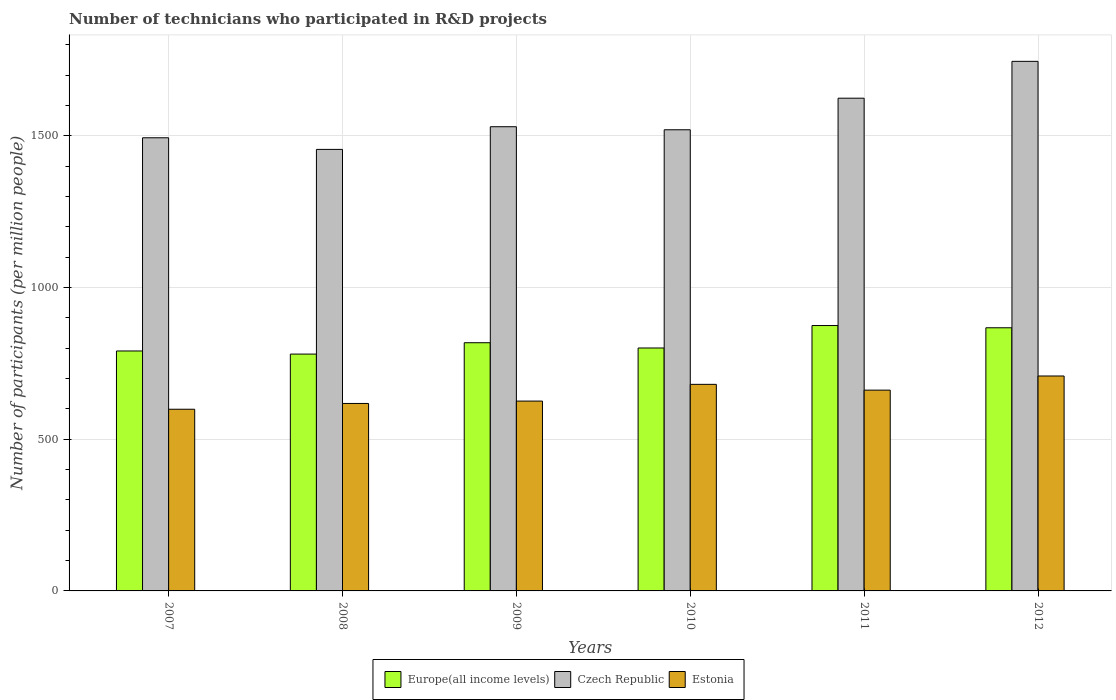How many different coloured bars are there?
Make the answer very short. 3. How many groups of bars are there?
Keep it short and to the point. 6. Are the number of bars per tick equal to the number of legend labels?
Your answer should be very brief. Yes. Are the number of bars on each tick of the X-axis equal?
Offer a terse response. Yes. How many bars are there on the 6th tick from the left?
Make the answer very short. 3. What is the label of the 6th group of bars from the left?
Ensure brevity in your answer.  2012. What is the number of technicians who participated in R&D projects in Czech Republic in 2009?
Keep it short and to the point. 1530.09. Across all years, what is the maximum number of technicians who participated in R&D projects in Czech Republic?
Your answer should be very brief. 1745.59. Across all years, what is the minimum number of technicians who participated in R&D projects in Estonia?
Your answer should be compact. 598.85. In which year was the number of technicians who participated in R&D projects in Estonia maximum?
Keep it short and to the point. 2012. What is the total number of technicians who participated in R&D projects in Estonia in the graph?
Ensure brevity in your answer.  3893.72. What is the difference between the number of technicians who participated in R&D projects in Estonia in 2008 and that in 2009?
Give a very brief answer. -7.8. What is the difference between the number of technicians who participated in R&D projects in Estonia in 2008 and the number of technicians who participated in R&D projects in Czech Republic in 2012?
Your answer should be very brief. -1127.65. What is the average number of technicians who participated in R&D projects in Europe(all income levels) per year?
Your response must be concise. 822.1. In the year 2009, what is the difference between the number of technicians who participated in R&D projects in Europe(all income levels) and number of technicians who participated in R&D projects in Czech Republic?
Provide a short and direct response. -712. What is the ratio of the number of technicians who participated in R&D projects in Estonia in 2007 to that in 2011?
Make the answer very short. 0.9. What is the difference between the highest and the second highest number of technicians who participated in R&D projects in Europe(all income levels)?
Your answer should be compact. 7.39. What is the difference between the highest and the lowest number of technicians who participated in R&D projects in Estonia?
Offer a terse response. 109.58. What does the 3rd bar from the left in 2008 represents?
Keep it short and to the point. Estonia. What does the 1st bar from the right in 2012 represents?
Make the answer very short. Estonia. Is it the case that in every year, the sum of the number of technicians who participated in R&D projects in Europe(all income levels) and number of technicians who participated in R&D projects in Estonia is greater than the number of technicians who participated in R&D projects in Czech Republic?
Your response must be concise. No. What is the difference between two consecutive major ticks on the Y-axis?
Provide a succinct answer. 500. Are the values on the major ticks of Y-axis written in scientific E-notation?
Your answer should be compact. No. Does the graph contain grids?
Provide a succinct answer. Yes. How many legend labels are there?
Keep it short and to the point. 3. How are the legend labels stacked?
Offer a terse response. Horizontal. What is the title of the graph?
Give a very brief answer. Number of technicians who participated in R&D projects. Does "East Asia (all income levels)" appear as one of the legend labels in the graph?
Offer a terse response. No. What is the label or title of the Y-axis?
Your answer should be very brief. Number of participants (per million people). What is the Number of participants (per million people) in Europe(all income levels) in 2007?
Offer a terse response. 790.9. What is the Number of participants (per million people) in Czech Republic in 2007?
Offer a terse response. 1493.68. What is the Number of participants (per million people) in Estonia in 2007?
Provide a short and direct response. 598.85. What is the Number of participants (per million people) of Europe(all income levels) in 2008?
Offer a terse response. 780.67. What is the Number of participants (per million people) of Czech Republic in 2008?
Ensure brevity in your answer.  1455.38. What is the Number of participants (per million people) in Estonia in 2008?
Your answer should be compact. 617.94. What is the Number of participants (per million people) of Europe(all income levels) in 2009?
Provide a short and direct response. 818.09. What is the Number of participants (per million people) in Czech Republic in 2009?
Your response must be concise. 1530.09. What is the Number of participants (per million people) of Estonia in 2009?
Your response must be concise. 625.74. What is the Number of participants (per million people) in Europe(all income levels) in 2010?
Your answer should be compact. 800.78. What is the Number of participants (per million people) in Czech Republic in 2010?
Offer a very short reply. 1520.06. What is the Number of participants (per million people) of Estonia in 2010?
Offer a very short reply. 680.89. What is the Number of participants (per million people) of Europe(all income levels) in 2011?
Offer a terse response. 874.77. What is the Number of participants (per million people) in Czech Republic in 2011?
Provide a succinct answer. 1624.14. What is the Number of participants (per million people) of Estonia in 2011?
Ensure brevity in your answer.  661.86. What is the Number of participants (per million people) of Europe(all income levels) in 2012?
Provide a succinct answer. 867.37. What is the Number of participants (per million people) of Czech Republic in 2012?
Offer a very short reply. 1745.59. What is the Number of participants (per million people) in Estonia in 2012?
Offer a terse response. 708.44. Across all years, what is the maximum Number of participants (per million people) of Europe(all income levels)?
Give a very brief answer. 874.77. Across all years, what is the maximum Number of participants (per million people) in Czech Republic?
Provide a succinct answer. 1745.59. Across all years, what is the maximum Number of participants (per million people) in Estonia?
Offer a very short reply. 708.44. Across all years, what is the minimum Number of participants (per million people) of Europe(all income levels)?
Your response must be concise. 780.67. Across all years, what is the minimum Number of participants (per million people) of Czech Republic?
Offer a very short reply. 1455.38. Across all years, what is the minimum Number of participants (per million people) in Estonia?
Provide a short and direct response. 598.85. What is the total Number of participants (per million people) in Europe(all income levels) in the graph?
Your response must be concise. 4932.59. What is the total Number of participants (per million people) of Czech Republic in the graph?
Keep it short and to the point. 9368.93. What is the total Number of participants (per million people) in Estonia in the graph?
Make the answer very short. 3893.72. What is the difference between the Number of participants (per million people) of Europe(all income levels) in 2007 and that in 2008?
Ensure brevity in your answer.  10.23. What is the difference between the Number of participants (per million people) of Czech Republic in 2007 and that in 2008?
Your answer should be very brief. 38.3. What is the difference between the Number of participants (per million people) of Estonia in 2007 and that in 2008?
Your answer should be compact. -19.08. What is the difference between the Number of participants (per million people) of Europe(all income levels) in 2007 and that in 2009?
Offer a very short reply. -27.19. What is the difference between the Number of participants (per million people) of Czech Republic in 2007 and that in 2009?
Provide a succinct answer. -36.41. What is the difference between the Number of participants (per million people) in Estonia in 2007 and that in 2009?
Your response must be concise. -26.89. What is the difference between the Number of participants (per million people) in Europe(all income levels) in 2007 and that in 2010?
Your response must be concise. -9.87. What is the difference between the Number of participants (per million people) in Czech Republic in 2007 and that in 2010?
Ensure brevity in your answer.  -26.38. What is the difference between the Number of participants (per million people) of Estonia in 2007 and that in 2010?
Give a very brief answer. -82.03. What is the difference between the Number of participants (per million people) of Europe(all income levels) in 2007 and that in 2011?
Your answer should be compact. -83.87. What is the difference between the Number of participants (per million people) in Czech Republic in 2007 and that in 2011?
Offer a very short reply. -130.45. What is the difference between the Number of participants (per million people) of Estonia in 2007 and that in 2011?
Keep it short and to the point. -63.01. What is the difference between the Number of participants (per million people) of Europe(all income levels) in 2007 and that in 2012?
Provide a short and direct response. -76.47. What is the difference between the Number of participants (per million people) of Czech Republic in 2007 and that in 2012?
Your answer should be very brief. -251.9. What is the difference between the Number of participants (per million people) in Estonia in 2007 and that in 2012?
Provide a short and direct response. -109.58. What is the difference between the Number of participants (per million people) of Europe(all income levels) in 2008 and that in 2009?
Your response must be concise. -37.42. What is the difference between the Number of participants (per million people) of Czech Republic in 2008 and that in 2009?
Offer a terse response. -74.72. What is the difference between the Number of participants (per million people) in Estonia in 2008 and that in 2009?
Keep it short and to the point. -7.8. What is the difference between the Number of participants (per million people) in Europe(all income levels) in 2008 and that in 2010?
Provide a succinct answer. -20.1. What is the difference between the Number of participants (per million people) of Czech Republic in 2008 and that in 2010?
Offer a very short reply. -64.68. What is the difference between the Number of participants (per million people) of Estonia in 2008 and that in 2010?
Your answer should be very brief. -62.95. What is the difference between the Number of participants (per million people) of Europe(all income levels) in 2008 and that in 2011?
Your answer should be very brief. -94.09. What is the difference between the Number of participants (per million people) in Czech Republic in 2008 and that in 2011?
Make the answer very short. -168.76. What is the difference between the Number of participants (per million people) of Estonia in 2008 and that in 2011?
Your answer should be compact. -43.93. What is the difference between the Number of participants (per million people) in Europe(all income levels) in 2008 and that in 2012?
Ensure brevity in your answer.  -86.7. What is the difference between the Number of participants (per million people) in Czech Republic in 2008 and that in 2012?
Ensure brevity in your answer.  -290.21. What is the difference between the Number of participants (per million people) of Estonia in 2008 and that in 2012?
Offer a terse response. -90.5. What is the difference between the Number of participants (per million people) in Europe(all income levels) in 2009 and that in 2010?
Your response must be concise. 17.32. What is the difference between the Number of participants (per million people) in Czech Republic in 2009 and that in 2010?
Provide a short and direct response. 10.04. What is the difference between the Number of participants (per million people) of Estonia in 2009 and that in 2010?
Provide a short and direct response. -55.14. What is the difference between the Number of participants (per million people) in Europe(all income levels) in 2009 and that in 2011?
Give a very brief answer. -56.67. What is the difference between the Number of participants (per million people) in Czech Republic in 2009 and that in 2011?
Give a very brief answer. -94.04. What is the difference between the Number of participants (per million people) in Estonia in 2009 and that in 2011?
Provide a succinct answer. -36.12. What is the difference between the Number of participants (per million people) in Europe(all income levels) in 2009 and that in 2012?
Make the answer very short. -49.28. What is the difference between the Number of participants (per million people) in Czech Republic in 2009 and that in 2012?
Ensure brevity in your answer.  -215.49. What is the difference between the Number of participants (per million people) in Estonia in 2009 and that in 2012?
Ensure brevity in your answer.  -82.7. What is the difference between the Number of participants (per million people) of Europe(all income levels) in 2010 and that in 2011?
Offer a terse response. -73.99. What is the difference between the Number of participants (per million people) of Czech Republic in 2010 and that in 2011?
Your response must be concise. -104.08. What is the difference between the Number of participants (per million people) of Estonia in 2010 and that in 2011?
Provide a succinct answer. 19.02. What is the difference between the Number of participants (per million people) in Europe(all income levels) in 2010 and that in 2012?
Offer a very short reply. -66.6. What is the difference between the Number of participants (per million people) in Czech Republic in 2010 and that in 2012?
Ensure brevity in your answer.  -225.53. What is the difference between the Number of participants (per million people) in Estonia in 2010 and that in 2012?
Ensure brevity in your answer.  -27.55. What is the difference between the Number of participants (per million people) in Europe(all income levels) in 2011 and that in 2012?
Your response must be concise. 7.39. What is the difference between the Number of participants (per million people) of Czech Republic in 2011 and that in 2012?
Your answer should be very brief. -121.45. What is the difference between the Number of participants (per million people) in Estonia in 2011 and that in 2012?
Your answer should be very brief. -46.57. What is the difference between the Number of participants (per million people) in Europe(all income levels) in 2007 and the Number of participants (per million people) in Czech Republic in 2008?
Provide a short and direct response. -664.47. What is the difference between the Number of participants (per million people) in Europe(all income levels) in 2007 and the Number of participants (per million people) in Estonia in 2008?
Offer a terse response. 172.97. What is the difference between the Number of participants (per million people) in Czech Republic in 2007 and the Number of participants (per million people) in Estonia in 2008?
Offer a terse response. 875.74. What is the difference between the Number of participants (per million people) in Europe(all income levels) in 2007 and the Number of participants (per million people) in Czech Republic in 2009?
Your answer should be very brief. -739.19. What is the difference between the Number of participants (per million people) in Europe(all income levels) in 2007 and the Number of participants (per million people) in Estonia in 2009?
Give a very brief answer. 165.16. What is the difference between the Number of participants (per million people) in Czech Republic in 2007 and the Number of participants (per million people) in Estonia in 2009?
Make the answer very short. 867.94. What is the difference between the Number of participants (per million people) in Europe(all income levels) in 2007 and the Number of participants (per million people) in Czech Republic in 2010?
Offer a terse response. -729.15. What is the difference between the Number of participants (per million people) of Europe(all income levels) in 2007 and the Number of participants (per million people) of Estonia in 2010?
Keep it short and to the point. 110.02. What is the difference between the Number of participants (per million people) in Czech Republic in 2007 and the Number of participants (per million people) in Estonia in 2010?
Your answer should be very brief. 812.8. What is the difference between the Number of participants (per million people) in Europe(all income levels) in 2007 and the Number of participants (per million people) in Czech Republic in 2011?
Offer a terse response. -833.23. What is the difference between the Number of participants (per million people) in Europe(all income levels) in 2007 and the Number of participants (per million people) in Estonia in 2011?
Provide a short and direct response. 129.04. What is the difference between the Number of participants (per million people) of Czech Republic in 2007 and the Number of participants (per million people) of Estonia in 2011?
Provide a short and direct response. 831.82. What is the difference between the Number of participants (per million people) of Europe(all income levels) in 2007 and the Number of participants (per million people) of Czech Republic in 2012?
Provide a short and direct response. -954.68. What is the difference between the Number of participants (per million people) in Europe(all income levels) in 2007 and the Number of participants (per million people) in Estonia in 2012?
Your answer should be compact. 82.46. What is the difference between the Number of participants (per million people) in Czech Republic in 2007 and the Number of participants (per million people) in Estonia in 2012?
Your response must be concise. 785.24. What is the difference between the Number of participants (per million people) in Europe(all income levels) in 2008 and the Number of participants (per million people) in Czech Republic in 2009?
Your answer should be very brief. -749.42. What is the difference between the Number of participants (per million people) in Europe(all income levels) in 2008 and the Number of participants (per million people) in Estonia in 2009?
Offer a terse response. 154.93. What is the difference between the Number of participants (per million people) in Czech Republic in 2008 and the Number of participants (per million people) in Estonia in 2009?
Provide a short and direct response. 829.63. What is the difference between the Number of participants (per million people) in Europe(all income levels) in 2008 and the Number of participants (per million people) in Czech Republic in 2010?
Make the answer very short. -739.38. What is the difference between the Number of participants (per million people) of Europe(all income levels) in 2008 and the Number of participants (per million people) of Estonia in 2010?
Offer a terse response. 99.79. What is the difference between the Number of participants (per million people) in Czech Republic in 2008 and the Number of participants (per million people) in Estonia in 2010?
Make the answer very short. 774.49. What is the difference between the Number of participants (per million people) of Europe(all income levels) in 2008 and the Number of participants (per million people) of Czech Republic in 2011?
Provide a short and direct response. -843.46. What is the difference between the Number of participants (per million people) of Europe(all income levels) in 2008 and the Number of participants (per million people) of Estonia in 2011?
Your answer should be very brief. 118.81. What is the difference between the Number of participants (per million people) of Czech Republic in 2008 and the Number of participants (per million people) of Estonia in 2011?
Offer a terse response. 793.51. What is the difference between the Number of participants (per million people) in Europe(all income levels) in 2008 and the Number of participants (per million people) in Czech Republic in 2012?
Your response must be concise. -964.91. What is the difference between the Number of participants (per million people) in Europe(all income levels) in 2008 and the Number of participants (per million people) in Estonia in 2012?
Keep it short and to the point. 72.24. What is the difference between the Number of participants (per million people) of Czech Republic in 2008 and the Number of participants (per million people) of Estonia in 2012?
Your answer should be very brief. 746.94. What is the difference between the Number of participants (per million people) of Europe(all income levels) in 2009 and the Number of participants (per million people) of Czech Republic in 2010?
Give a very brief answer. -701.96. What is the difference between the Number of participants (per million people) of Europe(all income levels) in 2009 and the Number of participants (per million people) of Estonia in 2010?
Your answer should be compact. 137.21. What is the difference between the Number of participants (per million people) of Czech Republic in 2009 and the Number of participants (per million people) of Estonia in 2010?
Give a very brief answer. 849.21. What is the difference between the Number of participants (per million people) in Europe(all income levels) in 2009 and the Number of participants (per million people) in Czech Republic in 2011?
Ensure brevity in your answer.  -806.04. What is the difference between the Number of participants (per million people) in Europe(all income levels) in 2009 and the Number of participants (per million people) in Estonia in 2011?
Provide a succinct answer. 156.23. What is the difference between the Number of participants (per million people) of Czech Republic in 2009 and the Number of participants (per million people) of Estonia in 2011?
Offer a terse response. 868.23. What is the difference between the Number of participants (per million people) of Europe(all income levels) in 2009 and the Number of participants (per million people) of Czech Republic in 2012?
Give a very brief answer. -927.49. What is the difference between the Number of participants (per million people) of Europe(all income levels) in 2009 and the Number of participants (per million people) of Estonia in 2012?
Provide a short and direct response. 109.66. What is the difference between the Number of participants (per million people) in Czech Republic in 2009 and the Number of participants (per million people) in Estonia in 2012?
Give a very brief answer. 821.66. What is the difference between the Number of participants (per million people) of Europe(all income levels) in 2010 and the Number of participants (per million people) of Czech Republic in 2011?
Ensure brevity in your answer.  -823.36. What is the difference between the Number of participants (per million people) in Europe(all income levels) in 2010 and the Number of participants (per million people) in Estonia in 2011?
Ensure brevity in your answer.  138.91. What is the difference between the Number of participants (per million people) in Czech Republic in 2010 and the Number of participants (per million people) in Estonia in 2011?
Ensure brevity in your answer.  858.19. What is the difference between the Number of participants (per million people) in Europe(all income levels) in 2010 and the Number of participants (per million people) in Czech Republic in 2012?
Offer a terse response. -944.81. What is the difference between the Number of participants (per million people) in Europe(all income levels) in 2010 and the Number of participants (per million people) in Estonia in 2012?
Give a very brief answer. 92.34. What is the difference between the Number of participants (per million people) of Czech Republic in 2010 and the Number of participants (per million people) of Estonia in 2012?
Make the answer very short. 811.62. What is the difference between the Number of participants (per million people) in Europe(all income levels) in 2011 and the Number of participants (per million people) in Czech Republic in 2012?
Offer a terse response. -870.82. What is the difference between the Number of participants (per million people) of Europe(all income levels) in 2011 and the Number of participants (per million people) of Estonia in 2012?
Give a very brief answer. 166.33. What is the difference between the Number of participants (per million people) of Czech Republic in 2011 and the Number of participants (per million people) of Estonia in 2012?
Keep it short and to the point. 915.7. What is the average Number of participants (per million people) in Europe(all income levels) per year?
Keep it short and to the point. 822.1. What is the average Number of participants (per million people) in Czech Republic per year?
Provide a succinct answer. 1561.49. What is the average Number of participants (per million people) of Estonia per year?
Provide a succinct answer. 648.95. In the year 2007, what is the difference between the Number of participants (per million people) of Europe(all income levels) and Number of participants (per million people) of Czech Republic?
Your answer should be very brief. -702.78. In the year 2007, what is the difference between the Number of participants (per million people) of Europe(all income levels) and Number of participants (per million people) of Estonia?
Make the answer very short. 192.05. In the year 2007, what is the difference between the Number of participants (per million people) in Czech Republic and Number of participants (per million people) in Estonia?
Your answer should be compact. 894.83. In the year 2008, what is the difference between the Number of participants (per million people) of Europe(all income levels) and Number of participants (per million people) of Czech Republic?
Give a very brief answer. -674.7. In the year 2008, what is the difference between the Number of participants (per million people) in Europe(all income levels) and Number of participants (per million people) in Estonia?
Your answer should be compact. 162.74. In the year 2008, what is the difference between the Number of participants (per million people) in Czech Republic and Number of participants (per million people) in Estonia?
Make the answer very short. 837.44. In the year 2009, what is the difference between the Number of participants (per million people) in Europe(all income levels) and Number of participants (per million people) in Czech Republic?
Your response must be concise. -712. In the year 2009, what is the difference between the Number of participants (per million people) of Europe(all income levels) and Number of participants (per million people) of Estonia?
Keep it short and to the point. 192.35. In the year 2009, what is the difference between the Number of participants (per million people) in Czech Republic and Number of participants (per million people) in Estonia?
Provide a succinct answer. 904.35. In the year 2010, what is the difference between the Number of participants (per million people) of Europe(all income levels) and Number of participants (per million people) of Czech Republic?
Your answer should be compact. -719.28. In the year 2010, what is the difference between the Number of participants (per million people) in Europe(all income levels) and Number of participants (per million people) in Estonia?
Ensure brevity in your answer.  119.89. In the year 2010, what is the difference between the Number of participants (per million people) of Czech Republic and Number of participants (per million people) of Estonia?
Provide a succinct answer. 839.17. In the year 2011, what is the difference between the Number of participants (per million people) of Europe(all income levels) and Number of participants (per million people) of Czech Republic?
Make the answer very short. -749.37. In the year 2011, what is the difference between the Number of participants (per million people) in Europe(all income levels) and Number of participants (per million people) in Estonia?
Provide a succinct answer. 212.9. In the year 2011, what is the difference between the Number of participants (per million people) of Czech Republic and Number of participants (per million people) of Estonia?
Provide a succinct answer. 962.27. In the year 2012, what is the difference between the Number of participants (per million people) of Europe(all income levels) and Number of participants (per million people) of Czech Republic?
Your answer should be very brief. -878.21. In the year 2012, what is the difference between the Number of participants (per million people) in Europe(all income levels) and Number of participants (per million people) in Estonia?
Your answer should be compact. 158.94. In the year 2012, what is the difference between the Number of participants (per million people) of Czech Republic and Number of participants (per million people) of Estonia?
Offer a terse response. 1037.15. What is the ratio of the Number of participants (per million people) in Europe(all income levels) in 2007 to that in 2008?
Your answer should be very brief. 1.01. What is the ratio of the Number of participants (per million people) in Czech Republic in 2007 to that in 2008?
Offer a terse response. 1.03. What is the ratio of the Number of participants (per million people) of Estonia in 2007 to that in 2008?
Keep it short and to the point. 0.97. What is the ratio of the Number of participants (per million people) in Europe(all income levels) in 2007 to that in 2009?
Offer a very short reply. 0.97. What is the ratio of the Number of participants (per million people) of Czech Republic in 2007 to that in 2009?
Your response must be concise. 0.98. What is the ratio of the Number of participants (per million people) of Czech Republic in 2007 to that in 2010?
Your answer should be compact. 0.98. What is the ratio of the Number of participants (per million people) in Estonia in 2007 to that in 2010?
Offer a terse response. 0.88. What is the ratio of the Number of participants (per million people) of Europe(all income levels) in 2007 to that in 2011?
Ensure brevity in your answer.  0.9. What is the ratio of the Number of participants (per million people) in Czech Republic in 2007 to that in 2011?
Provide a short and direct response. 0.92. What is the ratio of the Number of participants (per million people) in Estonia in 2007 to that in 2011?
Ensure brevity in your answer.  0.9. What is the ratio of the Number of participants (per million people) in Europe(all income levels) in 2007 to that in 2012?
Your answer should be compact. 0.91. What is the ratio of the Number of participants (per million people) in Czech Republic in 2007 to that in 2012?
Give a very brief answer. 0.86. What is the ratio of the Number of participants (per million people) in Estonia in 2007 to that in 2012?
Make the answer very short. 0.85. What is the ratio of the Number of participants (per million people) of Europe(all income levels) in 2008 to that in 2009?
Your answer should be compact. 0.95. What is the ratio of the Number of participants (per million people) of Czech Republic in 2008 to that in 2009?
Ensure brevity in your answer.  0.95. What is the ratio of the Number of participants (per million people) in Estonia in 2008 to that in 2009?
Offer a terse response. 0.99. What is the ratio of the Number of participants (per million people) in Europe(all income levels) in 2008 to that in 2010?
Keep it short and to the point. 0.97. What is the ratio of the Number of participants (per million people) of Czech Republic in 2008 to that in 2010?
Give a very brief answer. 0.96. What is the ratio of the Number of participants (per million people) of Estonia in 2008 to that in 2010?
Give a very brief answer. 0.91. What is the ratio of the Number of participants (per million people) of Europe(all income levels) in 2008 to that in 2011?
Provide a succinct answer. 0.89. What is the ratio of the Number of participants (per million people) in Czech Republic in 2008 to that in 2011?
Make the answer very short. 0.9. What is the ratio of the Number of participants (per million people) of Estonia in 2008 to that in 2011?
Give a very brief answer. 0.93. What is the ratio of the Number of participants (per million people) in Europe(all income levels) in 2008 to that in 2012?
Provide a succinct answer. 0.9. What is the ratio of the Number of participants (per million people) of Czech Republic in 2008 to that in 2012?
Make the answer very short. 0.83. What is the ratio of the Number of participants (per million people) in Estonia in 2008 to that in 2012?
Provide a succinct answer. 0.87. What is the ratio of the Number of participants (per million people) in Europe(all income levels) in 2009 to that in 2010?
Offer a very short reply. 1.02. What is the ratio of the Number of participants (per million people) of Czech Republic in 2009 to that in 2010?
Provide a short and direct response. 1.01. What is the ratio of the Number of participants (per million people) in Estonia in 2009 to that in 2010?
Offer a terse response. 0.92. What is the ratio of the Number of participants (per million people) of Europe(all income levels) in 2009 to that in 2011?
Make the answer very short. 0.94. What is the ratio of the Number of participants (per million people) of Czech Republic in 2009 to that in 2011?
Your response must be concise. 0.94. What is the ratio of the Number of participants (per million people) in Estonia in 2009 to that in 2011?
Ensure brevity in your answer.  0.95. What is the ratio of the Number of participants (per million people) of Europe(all income levels) in 2009 to that in 2012?
Offer a very short reply. 0.94. What is the ratio of the Number of participants (per million people) in Czech Republic in 2009 to that in 2012?
Give a very brief answer. 0.88. What is the ratio of the Number of participants (per million people) in Estonia in 2009 to that in 2012?
Give a very brief answer. 0.88. What is the ratio of the Number of participants (per million people) of Europe(all income levels) in 2010 to that in 2011?
Give a very brief answer. 0.92. What is the ratio of the Number of participants (per million people) in Czech Republic in 2010 to that in 2011?
Give a very brief answer. 0.94. What is the ratio of the Number of participants (per million people) in Estonia in 2010 to that in 2011?
Ensure brevity in your answer.  1.03. What is the ratio of the Number of participants (per million people) in Europe(all income levels) in 2010 to that in 2012?
Offer a very short reply. 0.92. What is the ratio of the Number of participants (per million people) of Czech Republic in 2010 to that in 2012?
Offer a very short reply. 0.87. What is the ratio of the Number of participants (per million people) of Estonia in 2010 to that in 2012?
Offer a terse response. 0.96. What is the ratio of the Number of participants (per million people) of Europe(all income levels) in 2011 to that in 2012?
Provide a short and direct response. 1.01. What is the ratio of the Number of participants (per million people) in Czech Republic in 2011 to that in 2012?
Provide a succinct answer. 0.93. What is the ratio of the Number of participants (per million people) in Estonia in 2011 to that in 2012?
Provide a succinct answer. 0.93. What is the difference between the highest and the second highest Number of participants (per million people) of Europe(all income levels)?
Your response must be concise. 7.39. What is the difference between the highest and the second highest Number of participants (per million people) of Czech Republic?
Provide a succinct answer. 121.45. What is the difference between the highest and the second highest Number of participants (per million people) in Estonia?
Keep it short and to the point. 27.55. What is the difference between the highest and the lowest Number of participants (per million people) of Europe(all income levels)?
Your answer should be compact. 94.09. What is the difference between the highest and the lowest Number of participants (per million people) of Czech Republic?
Make the answer very short. 290.21. What is the difference between the highest and the lowest Number of participants (per million people) of Estonia?
Offer a very short reply. 109.58. 